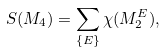Convert formula to latex. <formula><loc_0><loc_0><loc_500><loc_500>S ( M _ { 4 } ) = \sum _ { \{ E \} } \chi ( M ^ { E } _ { 2 } ) ,</formula> 